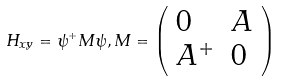Convert formula to latex. <formula><loc_0><loc_0><loc_500><loc_500>H _ { x y } = \psi ^ { + } M \psi , M = \left ( \begin{array} { l l } 0 & A \\ A ^ { + } & 0 \end{array} \right )</formula> 